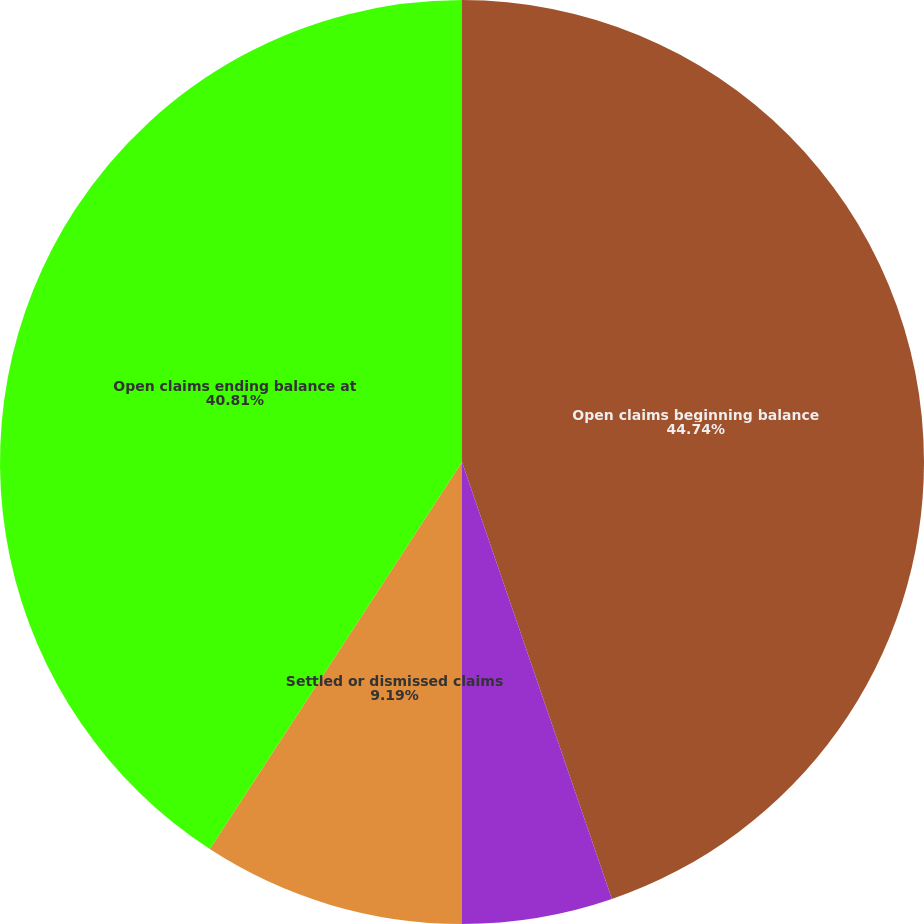<chart> <loc_0><loc_0><loc_500><loc_500><pie_chart><fcel>Open claims beginning balance<fcel>New claims<fcel>Settled or dismissed claims<fcel>Open claims ending balance at<nl><fcel>44.74%<fcel>5.26%<fcel>9.19%<fcel>40.81%<nl></chart> 